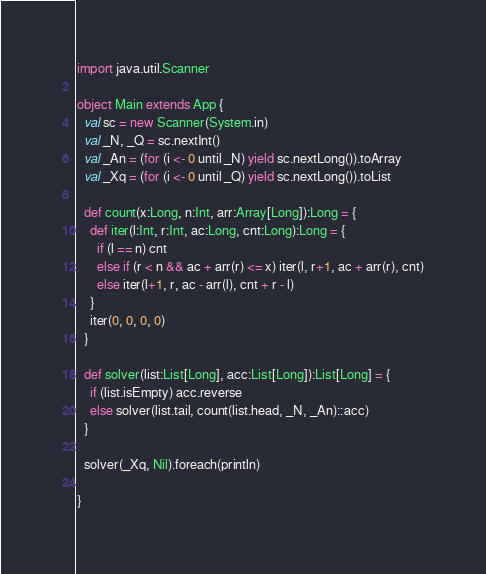<code> <loc_0><loc_0><loc_500><loc_500><_Scala_>import java.util.Scanner

object Main extends App { 
  val sc = new Scanner(System.in)
  val _N, _Q = sc.nextInt()
  val _An = (for (i <- 0 until _N) yield sc.nextLong()).toArray
  val _Xq = (for (i <- 0 until _Q) yield sc.nextLong()).toList

  def count(x:Long, n:Int, arr:Array[Long]):Long = {
    def iter(l:Int, r:Int, ac:Long, cnt:Long):Long = {
      if (l == n) cnt
      else if (r < n && ac + arr(r) <= x) iter(l, r+1, ac + arr(r), cnt)
      else iter(l+1, r, ac - arr(l), cnt + r - l)
    }
    iter(0, 0, 0, 0)
  } 

  def solver(list:List[Long], acc:List[Long]):List[Long] = {
    if (list.isEmpty) acc.reverse
    else solver(list.tail, count(list.head, _N, _An)::acc)
  }

  solver(_Xq, Nil).foreach(println)

}

</code> 